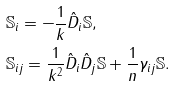Convert formula to latex. <formula><loc_0><loc_0><loc_500><loc_500>& { \mathbb { S } } _ { i } = - \frac { 1 } { k } \hat { D } _ { i } { \mathbb { S } } , \\ & { \mathbb { S } } _ { i j } = \frac { 1 } { k ^ { 2 } } \hat { D } _ { i } \hat { D } _ { j } { \mathbb { S } } + \frac { 1 } { n } \gamma _ { i j } { \mathbb { S } } .</formula> 